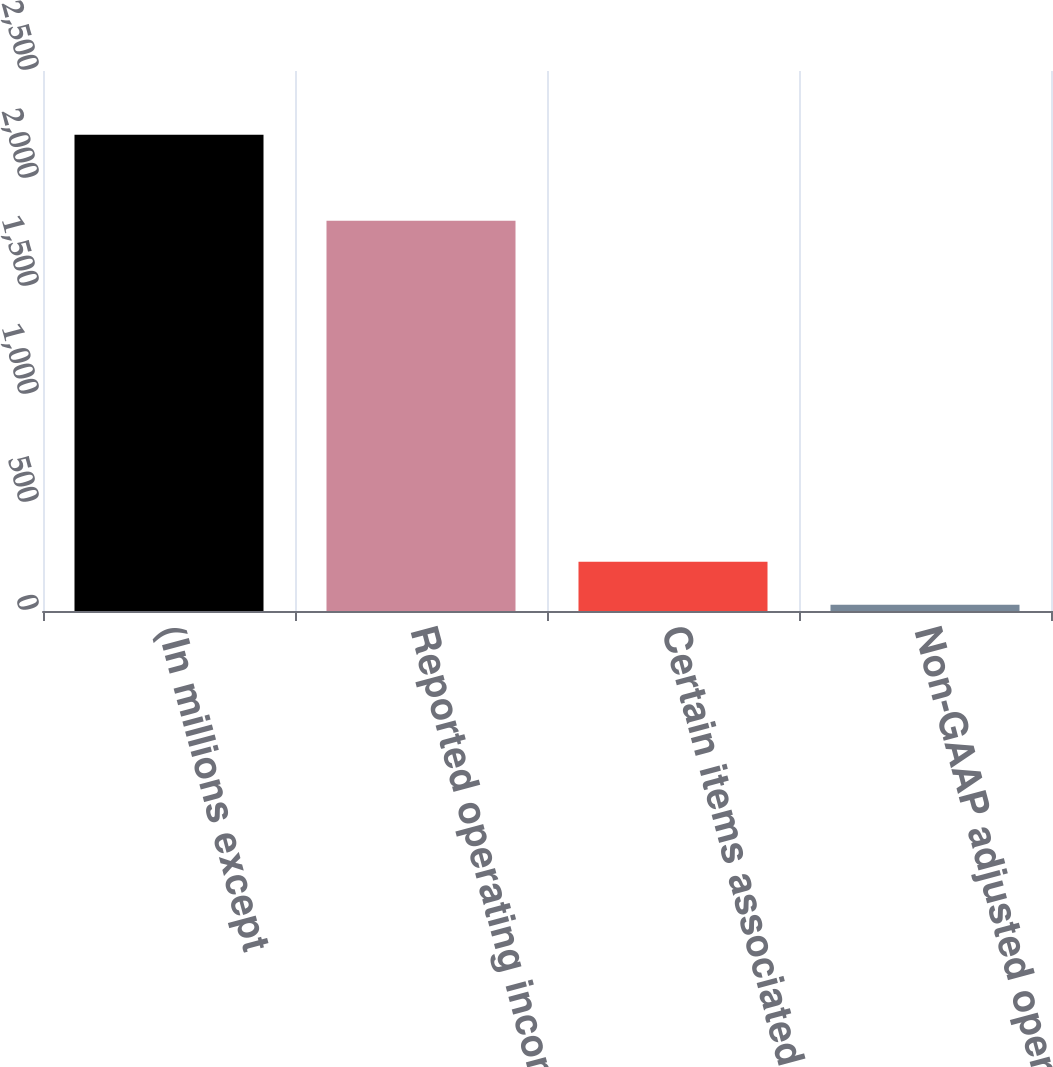<chart> <loc_0><loc_0><loc_500><loc_500><bar_chart><fcel>(In millions except<fcel>Reported operating income -<fcel>Certain items associated with<fcel>Non-GAAP adjusted operating<nl><fcel>2204.4<fcel>1807<fcel>227.7<fcel>29<nl></chart> 